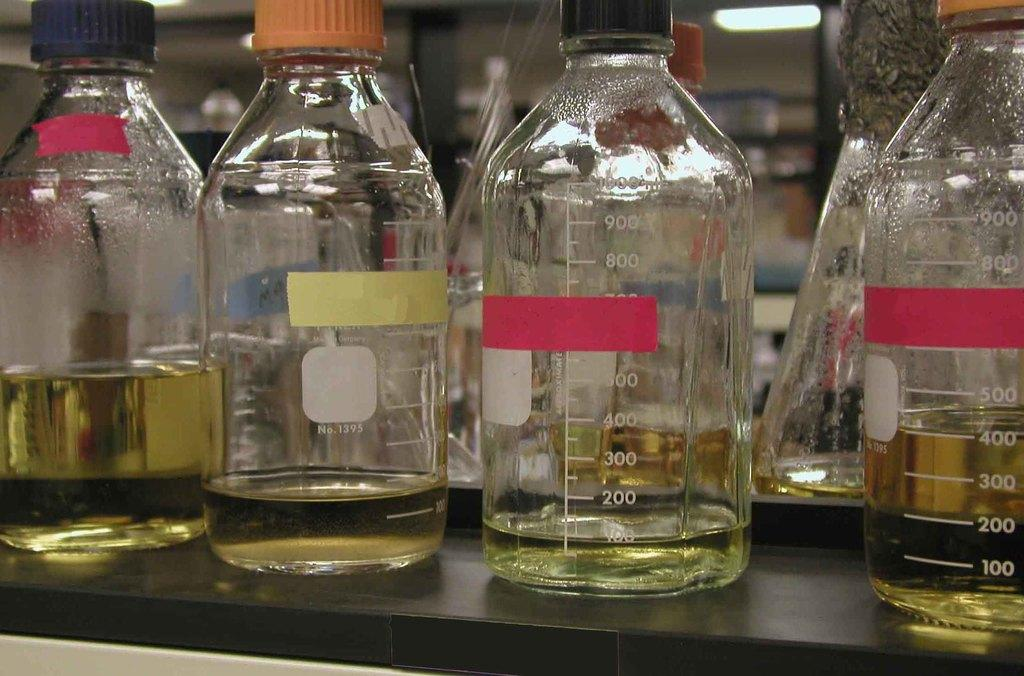What objects are present in the image? There are bottles in the image. What is inside the bottles? There is liquid in the bottles. Are there any decorations or labels on the bottles? Yes, there are stickers on the bottles. Can you see a donkey standing near the bottles in the image? No, there is no donkey present in the image. 